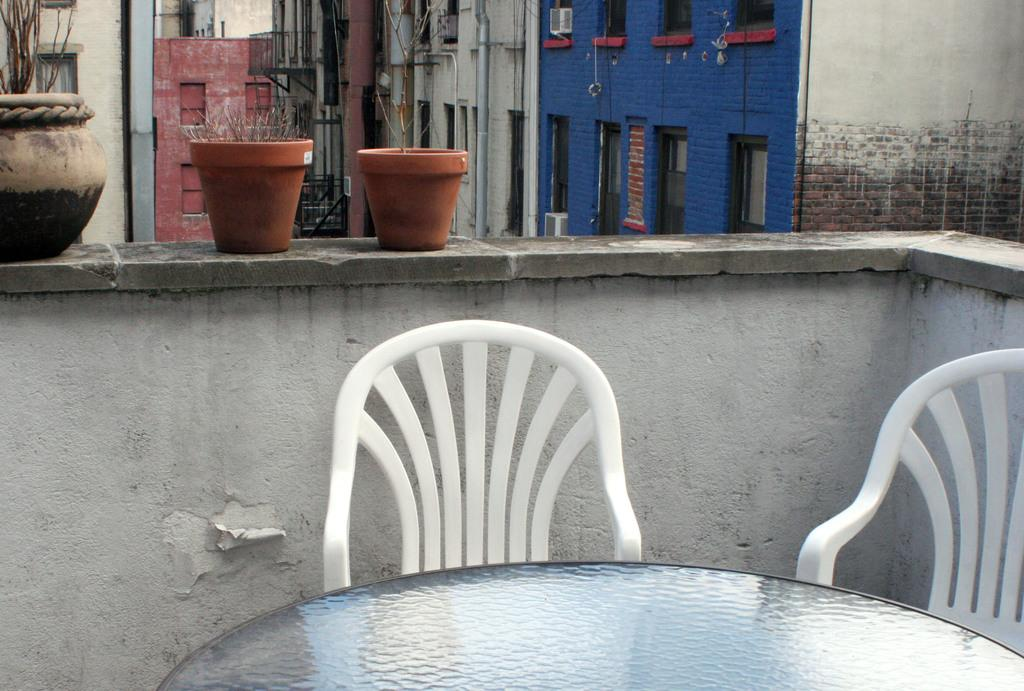What is hanging on the wall in the image? There are plant pots on the wall. What furniture is in front of the wall? There are chairs in front of the wall. What can be seen in the distance behind the wall? There are buildings visible in the background. What type of butter is being used to grease the playground equipment in the image? There is no butter or playground equipment present in the image. What is the engine used for in the image? There is no engine present in the image. 